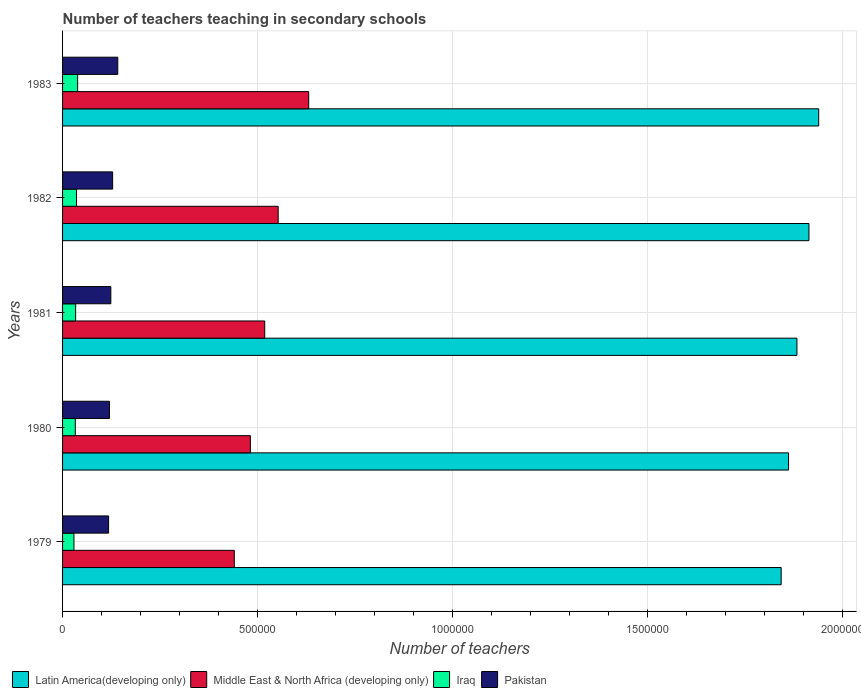How many different coloured bars are there?
Your answer should be compact. 4. How many groups of bars are there?
Give a very brief answer. 5. Are the number of bars per tick equal to the number of legend labels?
Offer a very short reply. Yes. Are the number of bars on each tick of the Y-axis equal?
Your response must be concise. Yes. How many bars are there on the 4th tick from the top?
Offer a terse response. 4. What is the label of the 3rd group of bars from the top?
Keep it short and to the point. 1981. In how many cases, is the number of bars for a given year not equal to the number of legend labels?
Offer a very short reply. 0. What is the number of teachers teaching in secondary schools in Pakistan in 1982?
Give a very brief answer. 1.28e+05. Across all years, what is the maximum number of teachers teaching in secondary schools in Pakistan?
Provide a succinct answer. 1.42e+05. Across all years, what is the minimum number of teachers teaching in secondary schools in Middle East & North Africa (developing only)?
Provide a short and direct response. 4.41e+05. In which year was the number of teachers teaching in secondary schools in Middle East & North Africa (developing only) minimum?
Ensure brevity in your answer.  1979. What is the total number of teachers teaching in secondary schools in Latin America(developing only) in the graph?
Your answer should be very brief. 9.44e+06. What is the difference between the number of teachers teaching in secondary schools in Latin America(developing only) in 1980 and that in 1983?
Your answer should be very brief. -7.73e+04. What is the difference between the number of teachers teaching in secondary schools in Iraq in 1983 and the number of teachers teaching in secondary schools in Middle East & North Africa (developing only) in 1982?
Keep it short and to the point. -5.14e+05. What is the average number of teachers teaching in secondary schools in Pakistan per year?
Provide a short and direct response. 1.26e+05. In the year 1979, what is the difference between the number of teachers teaching in secondary schools in Latin America(developing only) and number of teachers teaching in secondary schools in Iraq?
Your answer should be compact. 1.81e+06. In how many years, is the number of teachers teaching in secondary schools in Latin America(developing only) greater than 1200000 ?
Provide a short and direct response. 5. What is the ratio of the number of teachers teaching in secondary schools in Pakistan in 1980 to that in 1982?
Offer a very short reply. 0.94. Is the number of teachers teaching in secondary schools in Pakistan in 1980 less than that in 1982?
Your response must be concise. Yes. Is the difference between the number of teachers teaching in secondary schools in Latin America(developing only) in 1979 and 1983 greater than the difference between the number of teachers teaching in secondary schools in Iraq in 1979 and 1983?
Your answer should be compact. No. What is the difference between the highest and the second highest number of teachers teaching in secondary schools in Latin America(developing only)?
Offer a very short reply. 2.49e+04. What is the difference between the highest and the lowest number of teachers teaching in secondary schools in Latin America(developing only)?
Your answer should be very brief. 9.62e+04. In how many years, is the number of teachers teaching in secondary schools in Iraq greater than the average number of teachers teaching in secondary schools in Iraq taken over all years?
Your answer should be compact. 2. Is the sum of the number of teachers teaching in secondary schools in Pakistan in 1981 and 1983 greater than the maximum number of teachers teaching in secondary schools in Latin America(developing only) across all years?
Make the answer very short. No. Is it the case that in every year, the sum of the number of teachers teaching in secondary schools in Middle East & North Africa (developing only) and number of teachers teaching in secondary schools in Iraq is greater than the sum of number of teachers teaching in secondary schools in Latin America(developing only) and number of teachers teaching in secondary schools in Pakistan?
Make the answer very short. Yes. What does the 2nd bar from the top in 1983 represents?
Give a very brief answer. Iraq. What does the 2nd bar from the bottom in 1981 represents?
Provide a short and direct response. Middle East & North Africa (developing only). Is it the case that in every year, the sum of the number of teachers teaching in secondary schools in Middle East & North Africa (developing only) and number of teachers teaching in secondary schools in Latin America(developing only) is greater than the number of teachers teaching in secondary schools in Iraq?
Give a very brief answer. Yes. How many bars are there?
Make the answer very short. 20. Are all the bars in the graph horizontal?
Provide a succinct answer. Yes. How many years are there in the graph?
Make the answer very short. 5. Are the values on the major ticks of X-axis written in scientific E-notation?
Provide a succinct answer. No. Does the graph contain grids?
Provide a short and direct response. Yes. How many legend labels are there?
Your response must be concise. 4. How are the legend labels stacked?
Provide a succinct answer. Horizontal. What is the title of the graph?
Make the answer very short. Number of teachers teaching in secondary schools. Does "Brunei Darussalam" appear as one of the legend labels in the graph?
Your answer should be compact. No. What is the label or title of the X-axis?
Offer a very short reply. Number of teachers. What is the label or title of the Y-axis?
Give a very brief answer. Years. What is the Number of teachers of Latin America(developing only) in 1979?
Offer a very short reply. 1.84e+06. What is the Number of teachers in Middle East & North Africa (developing only) in 1979?
Give a very brief answer. 4.41e+05. What is the Number of teachers of Iraq in 1979?
Your answer should be very brief. 2.92e+04. What is the Number of teachers of Pakistan in 1979?
Offer a terse response. 1.18e+05. What is the Number of teachers in Latin America(developing only) in 1980?
Your response must be concise. 1.86e+06. What is the Number of teachers in Middle East & North Africa (developing only) in 1980?
Your answer should be compact. 4.82e+05. What is the Number of teachers in Iraq in 1980?
Offer a very short reply. 3.27e+04. What is the Number of teachers of Pakistan in 1980?
Provide a succinct answer. 1.20e+05. What is the Number of teachers of Latin America(developing only) in 1981?
Your answer should be very brief. 1.88e+06. What is the Number of teachers in Middle East & North Africa (developing only) in 1981?
Provide a succinct answer. 5.19e+05. What is the Number of teachers in Iraq in 1981?
Your answer should be compact. 3.35e+04. What is the Number of teachers in Pakistan in 1981?
Provide a short and direct response. 1.24e+05. What is the Number of teachers in Latin America(developing only) in 1982?
Offer a very short reply. 1.91e+06. What is the Number of teachers in Middle East & North Africa (developing only) in 1982?
Provide a succinct answer. 5.53e+05. What is the Number of teachers in Iraq in 1982?
Your answer should be very brief. 3.58e+04. What is the Number of teachers in Pakistan in 1982?
Offer a very short reply. 1.28e+05. What is the Number of teachers of Latin America(developing only) in 1983?
Your answer should be very brief. 1.94e+06. What is the Number of teachers in Middle East & North Africa (developing only) in 1983?
Provide a succinct answer. 6.31e+05. What is the Number of teachers of Iraq in 1983?
Provide a short and direct response. 3.87e+04. What is the Number of teachers in Pakistan in 1983?
Offer a very short reply. 1.42e+05. Across all years, what is the maximum Number of teachers in Latin America(developing only)?
Keep it short and to the point. 1.94e+06. Across all years, what is the maximum Number of teachers in Middle East & North Africa (developing only)?
Provide a short and direct response. 6.31e+05. Across all years, what is the maximum Number of teachers in Iraq?
Keep it short and to the point. 3.87e+04. Across all years, what is the maximum Number of teachers of Pakistan?
Keep it short and to the point. 1.42e+05. Across all years, what is the minimum Number of teachers in Latin America(developing only)?
Make the answer very short. 1.84e+06. Across all years, what is the minimum Number of teachers of Middle East & North Africa (developing only)?
Your answer should be compact. 4.41e+05. Across all years, what is the minimum Number of teachers of Iraq?
Your answer should be very brief. 2.92e+04. Across all years, what is the minimum Number of teachers of Pakistan?
Offer a terse response. 1.18e+05. What is the total Number of teachers in Latin America(developing only) in the graph?
Provide a succinct answer. 9.44e+06. What is the total Number of teachers of Middle East & North Africa (developing only) in the graph?
Provide a succinct answer. 2.63e+06. What is the total Number of teachers of Iraq in the graph?
Keep it short and to the point. 1.70e+05. What is the total Number of teachers of Pakistan in the graph?
Keep it short and to the point. 6.32e+05. What is the difference between the Number of teachers of Latin America(developing only) in 1979 and that in 1980?
Your answer should be very brief. -1.89e+04. What is the difference between the Number of teachers of Middle East & North Africa (developing only) in 1979 and that in 1980?
Offer a terse response. -4.12e+04. What is the difference between the Number of teachers of Iraq in 1979 and that in 1980?
Provide a succinct answer. -3478. What is the difference between the Number of teachers in Pakistan in 1979 and that in 1980?
Ensure brevity in your answer.  -2204. What is the difference between the Number of teachers of Latin America(developing only) in 1979 and that in 1981?
Keep it short and to the point. -4.04e+04. What is the difference between the Number of teachers of Middle East & North Africa (developing only) in 1979 and that in 1981?
Provide a succinct answer. -7.81e+04. What is the difference between the Number of teachers of Iraq in 1979 and that in 1981?
Your answer should be very brief. -4305. What is the difference between the Number of teachers of Pakistan in 1979 and that in 1981?
Provide a succinct answer. -5740. What is the difference between the Number of teachers of Latin America(developing only) in 1979 and that in 1982?
Make the answer very short. -7.13e+04. What is the difference between the Number of teachers of Middle East & North Africa (developing only) in 1979 and that in 1982?
Give a very brief answer. -1.13e+05. What is the difference between the Number of teachers in Iraq in 1979 and that in 1982?
Provide a short and direct response. -6616. What is the difference between the Number of teachers of Pakistan in 1979 and that in 1982?
Offer a terse response. -1.04e+04. What is the difference between the Number of teachers of Latin America(developing only) in 1979 and that in 1983?
Offer a very short reply. -9.62e+04. What is the difference between the Number of teachers of Middle East & North Africa (developing only) in 1979 and that in 1983?
Make the answer very short. -1.91e+05. What is the difference between the Number of teachers in Iraq in 1979 and that in 1983?
Offer a very short reply. -9469. What is the difference between the Number of teachers of Pakistan in 1979 and that in 1983?
Offer a terse response. -2.35e+04. What is the difference between the Number of teachers in Latin America(developing only) in 1980 and that in 1981?
Ensure brevity in your answer.  -2.15e+04. What is the difference between the Number of teachers in Middle East & North Africa (developing only) in 1980 and that in 1981?
Keep it short and to the point. -3.68e+04. What is the difference between the Number of teachers of Iraq in 1980 and that in 1981?
Offer a very short reply. -827. What is the difference between the Number of teachers of Pakistan in 1980 and that in 1981?
Your answer should be very brief. -3536. What is the difference between the Number of teachers of Latin America(developing only) in 1980 and that in 1982?
Your answer should be compact. -5.24e+04. What is the difference between the Number of teachers in Middle East & North Africa (developing only) in 1980 and that in 1982?
Offer a terse response. -7.13e+04. What is the difference between the Number of teachers in Iraq in 1980 and that in 1982?
Give a very brief answer. -3138. What is the difference between the Number of teachers in Pakistan in 1980 and that in 1982?
Ensure brevity in your answer.  -8186. What is the difference between the Number of teachers of Latin America(developing only) in 1980 and that in 1983?
Give a very brief answer. -7.73e+04. What is the difference between the Number of teachers of Middle East & North Africa (developing only) in 1980 and that in 1983?
Ensure brevity in your answer.  -1.50e+05. What is the difference between the Number of teachers of Iraq in 1980 and that in 1983?
Provide a short and direct response. -5991. What is the difference between the Number of teachers in Pakistan in 1980 and that in 1983?
Keep it short and to the point. -2.13e+04. What is the difference between the Number of teachers of Latin America(developing only) in 1981 and that in 1982?
Provide a succinct answer. -3.09e+04. What is the difference between the Number of teachers in Middle East & North Africa (developing only) in 1981 and that in 1982?
Ensure brevity in your answer.  -3.45e+04. What is the difference between the Number of teachers of Iraq in 1981 and that in 1982?
Offer a very short reply. -2311. What is the difference between the Number of teachers of Pakistan in 1981 and that in 1982?
Keep it short and to the point. -4650. What is the difference between the Number of teachers in Latin America(developing only) in 1981 and that in 1983?
Your answer should be very brief. -5.58e+04. What is the difference between the Number of teachers of Middle East & North Africa (developing only) in 1981 and that in 1983?
Give a very brief answer. -1.13e+05. What is the difference between the Number of teachers of Iraq in 1981 and that in 1983?
Give a very brief answer. -5164. What is the difference between the Number of teachers of Pakistan in 1981 and that in 1983?
Your answer should be very brief. -1.78e+04. What is the difference between the Number of teachers in Latin America(developing only) in 1982 and that in 1983?
Keep it short and to the point. -2.49e+04. What is the difference between the Number of teachers of Middle East & North Africa (developing only) in 1982 and that in 1983?
Your answer should be very brief. -7.83e+04. What is the difference between the Number of teachers of Iraq in 1982 and that in 1983?
Your answer should be very brief. -2853. What is the difference between the Number of teachers of Pakistan in 1982 and that in 1983?
Give a very brief answer. -1.31e+04. What is the difference between the Number of teachers in Latin America(developing only) in 1979 and the Number of teachers in Middle East & North Africa (developing only) in 1980?
Keep it short and to the point. 1.36e+06. What is the difference between the Number of teachers of Latin America(developing only) in 1979 and the Number of teachers of Iraq in 1980?
Make the answer very short. 1.81e+06. What is the difference between the Number of teachers of Latin America(developing only) in 1979 and the Number of teachers of Pakistan in 1980?
Ensure brevity in your answer.  1.72e+06. What is the difference between the Number of teachers of Middle East & North Africa (developing only) in 1979 and the Number of teachers of Iraq in 1980?
Give a very brief answer. 4.08e+05. What is the difference between the Number of teachers in Middle East & North Africa (developing only) in 1979 and the Number of teachers in Pakistan in 1980?
Offer a very short reply. 3.20e+05. What is the difference between the Number of teachers of Iraq in 1979 and the Number of teachers of Pakistan in 1980?
Make the answer very short. -9.11e+04. What is the difference between the Number of teachers in Latin America(developing only) in 1979 and the Number of teachers in Middle East & North Africa (developing only) in 1981?
Offer a very short reply. 1.32e+06. What is the difference between the Number of teachers in Latin America(developing only) in 1979 and the Number of teachers in Iraq in 1981?
Ensure brevity in your answer.  1.81e+06. What is the difference between the Number of teachers in Latin America(developing only) in 1979 and the Number of teachers in Pakistan in 1981?
Your answer should be very brief. 1.72e+06. What is the difference between the Number of teachers of Middle East & North Africa (developing only) in 1979 and the Number of teachers of Iraq in 1981?
Give a very brief answer. 4.07e+05. What is the difference between the Number of teachers of Middle East & North Africa (developing only) in 1979 and the Number of teachers of Pakistan in 1981?
Provide a succinct answer. 3.17e+05. What is the difference between the Number of teachers in Iraq in 1979 and the Number of teachers in Pakistan in 1981?
Offer a very short reply. -9.46e+04. What is the difference between the Number of teachers of Latin America(developing only) in 1979 and the Number of teachers of Middle East & North Africa (developing only) in 1982?
Offer a very short reply. 1.29e+06. What is the difference between the Number of teachers of Latin America(developing only) in 1979 and the Number of teachers of Iraq in 1982?
Keep it short and to the point. 1.81e+06. What is the difference between the Number of teachers of Latin America(developing only) in 1979 and the Number of teachers of Pakistan in 1982?
Provide a succinct answer. 1.71e+06. What is the difference between the Number of teachers of Middle East & North Africa (developing only) in 1979 and the Number of teachers of Iraq in 1982?
Offer a terse response. 4.05e+05. What is the difference between the Number of teachers in Middle East & North Africa (developing only) in 1979 and the Number of teachers in Pakistan in 1982?
Give a very brief answer. 3.12e+05. What is the difference between the Number of teachers of Iraq in 1979 and the Number of teachers of Pakistan in 1982?
Offer a very short reply. -9.93e+04. What is the difference between the Number of teachers of Latin America(developing only) in 1979 and the Number of teachers of Middle East & North Africa (developing only) in 1983?
Your response must be concise. 1.21e+06. What is the difference between the Number of teachers in Latin America(developing only) in 1979 and the Number of teachers in Iraq in 1983?
Your answer should be compact. 1.80e+06. What is the difference between the Number of teachers in Latin America(developing only) in 1979 and the Number of teachers in Pakistan in 1983?
Your response must be concise. 1.70e+06. What is the difference between the Number of teachers of Middle East & North Africa (developing only) in 1979 and the Number of teachers of Iraq in 1983?
Your response must be concise. 4.02e+05. What is the difference between the Number of teachers of Middle East & North Africa (developing only) in 1979 and the Number of teachers of Pakistan in 1983?
Your response must be concise. 2.99e+05. What is the difference between the Number of teachers in Iraq in 1979 and the Number of teachers in Pakistan in 1983?
Give a very brief answer. -1.12e+05. What is the difference between the Number of teachers of Latin America(developing only) in 1980 and the Number of teachers of Middle East & North Africa (developing only) in 1981?
Offer a very short reply. 1.34e+06. What is the difference between the Number of teachers of Latin America(developing only) in 1980 and the Number of teachers of Iraq in 1981?
Ensure brevity in your answer.  1.83e+06. What is the difference between the Number of teachers in Latin America(developing only) in 1980 and the Number of teachers in Pakistan in 1981?
Make the answer very short. 1.74e+06. What is the difference between the Number of teachers of Middle East & North Africa (developing only) in 1980 and the Number of teachers of Iraq in 1981?
Provide a succinct answer. 4.48e+05. What is the difference between the Number of teachers of Middle East & North Africa (developing only) in 1980 and the Number of teachers of Pakistan in 1981?
Offer a terse response. 3.58e+05. What is the difference between the Number of teachers in Iraq in 1980 and the Number of teachers in Pakistan in 1981?
Your answer should be compact. -9.11e+04. What is the difference between the Number of teachers of Latin America(developing only) in 1980 and the Number of teachers of Middle East & North Africa (developing only) in 1982?
Provide a short and direct response. 1.31e+06. What is the difference between the Number of teachers of Latin America(developing only) in 1980 and the Number of teachers of Iraq in 1982?
Your answer should be compact. 1.83e+06. What is the difference between the Number of teachers of Latin America(developing only) in 1980 and the Number of teachers of Pakistan in 1982?
Ensure brevity in your answer.  1.73e+06. What is the difference between the Number of teachers of Middle East & North Africa (developing only) in 1980 and the Number of teachers of Iraq in 1982?
Ensure brevity in your answer.  4.46e+05. What is the difference between the Number of teachers in Middle East & North Africa (developing only) in 1980 and the Number of teachers in Pakistan in 1982?
Offer a terse response. 3.53e+05. What is the difference between the Number of teachers of Iraq in 1980 and the Number of teachers of Pakistan in 1982?
Your answer should be compact. -9.58e+04. What is the difference between the Number of teachers in Latin America(developing only) in 1980 and the Number of teachers in Middle East & North Africa (developing only) in 1983?
Make the answer very short. 1.23e+06. What is the difference between the Number of teachers in Latin America(developing only) in 1980 and the Number of teachers in Iraq in 1983?
Your answer should be very brief. 1.82e+06. What is the difference between the Number of teachers of Latin America(developing only) in 1980 and the Number of teachers of Pakistan in 1983?
Offer a terse response. 1.72e+06. What is the difference between the Number of teachers in Middle East & North Africa (developing only) in 1980 and the Number of teachers in Iraq in 1983?
Give a very brief answer. 4.43e+05. What is the difference between the Number of teachers in Middle East & North Africa (developing only) in 1980 and the Number of teachers in Pakistan in 1983?
Keep it short and to the point. 3.40e+05. What is the difference between the Number of teachers in Iraq in 1980 and the Number of teachers in Pakistan in 1983?
Your answer should be compact. -1.09e+05. What is the difference between the Number of teachers in Latin America(developing only) in 1981 and the Number of teachers in Middle East & North Africa (developing only) in 1982?
Provide a short and direct response. 1.33e+06. What is the difference between the Number of teachers in Latin America(developing only) in 1981 and the Number of teachers in Iraq in 1982?
Your answer should be very brief. 1.85e+06. What is the difference between the Number of teachers of Latin America(developing only) in 1981 and the Number of teachers of Pakistan in 1982?
Offer a terse response. 1.76e+06. What is the difference between the Number of teachers of Middle East & North Africa (developing only) in 1981 and the Number of teachers of Iraq in 1982?
Your answer should be very brief. 4.83e+05. What is the difference between the Number of teachers in Middle East & North Africa (developing only) in 1981 and the Number of teachers in Pakistan in 1982?
Make the answer very short. 3.90e+05. What is the difference between the Number of teachers of Iraq in 1981 and the Number of teachers of Pakistan in 1982?
Offer a terse response. -9.50e+04. What is the difference between the Number of teachers in Latin America(developing only) in 1981 and the Number of teachers in Middle East & North Africa (developing only) in 1983?
Your answer should be compact. 1.25e+06. What is the difference between the Number of teachers in Latin America(developing only) in 1981 and the Number of teachers in Iraq in 1983?
Provide a short and direct response. 1.85e+06. What is the difference between the Number of teachers of Latin America(developing only) in 1981 and the Number of teachers of Pakistan in 1983?
Provide a succinct answer. 1.74e+06. What is the difference between the Number of teachers in Middle East & North Africa (developing only) in 1981 and the Number of teachers in Iraq in 1983?
Your answer should be compact. 4.80e+05. What is the difference between the Number of teachers in Middle East & North Africa (developing only) in 1981 and the Number of teachers in Pakistan in 1983?
Your answer should be compact. 3.77e+05. What is the difference between the Number of teachers in Iraq in 1981 and the Number of teachers in Pakistan in 1983?
Offer a very short reply. -1.08e+05. What is the difference between the Number of teachers in Latin America(developing only) in 1982 and the Number of teachers in Middle East & North Africa (developing only) in 1983?
Provide a succinct answer. 1.28e+06. What is the difference between the Number of teachers in Latin America(developing only) in 1982 and the Number of teachers in Iraq in 1983?
Keep it short and to the point. 1.88e+06. What is the difference between the Number of teachers of Latin America(developing only) in 1982 and the Number of teachers of Pakistan in 1983?
Your answer should be compact. 1.77e+06. What is the difference between the Number of teachers in Middle East & North Africa (developing only) in 1982 and the Number of teachers in Iraq in 1983?
Provide a succinct answer. 5.14e+05. What is the difference between the Number of teachers in Middle East & North Africa (developing only) in 1982 and the Number of teachers in Pakistan in 1983?
Your response must be concise. 4.11e+05. What is the difference between the Number of teachers in Iraq in 1982 and the Number of teachers in Pakistan in 1983?
Offer a very short reply. -1.06e+05. What is the average Number of teachers of Latin America(developing only) per year?
Offer a terse response. 1.89e+06. What is the average Number of teachers in Middle East & North Africa (developing only) per year?
Provide a succinct answer. 5.25e+05. What is the average Number of teachers in Iraq per year?
Your response must be concise. 3.40e+04. What is the average Number of teachers of Pakistan per year?
Keep it short and to the point. 1.26e+05. In the year 1979, what is the difference between the Number of teachers in Latin America(developing only) and Number of teachers in Middle East & North Africa (developing only)?
Provide a succinct answer. 1.40e+06. In the year 1979, what is the difference between the Number of teachers of Latin America(developing only) and Number of teachers of Iraq?
Give a very brief answer. 1.81e+06. In the year 1979, what is the difference between the Number of teachers in Latin America(developing only) and Number of teachers in Pakistan?
Offer a very short reply. 1.73e+06. In the year 1979, what is the difference between the Number of teachers in Middle East & North Africa (developing only) and Number of teachers in Iraq?
Make the answer very short. 4.11e+05. In the year 1979, what is the difference between the Number of teachers of Middle East & North Africa (developing only) and Number of teachers of Pakistan?
Offer a terse response. 3.22e+05. In the year 1979, what is the difference between the Number of teachers in Iraq and Number of teachers in Pakistan?
Your answer should be very brief. -8.89e+04. In the year 1980, what is the difference between the Number of teachers of Latin America(developing only) and Number of teachers of Middle East & North Africa (developing only)?
Offer a very short reply. 1.38e+06. In the year 1980, what is the difference between the Number of teachers in Latin America(developing only) and Number of teachers in Iraq?
Make the answer very short. 1.83e+06. In the year 1980, what is the difference between the Number of teachers in Latin America(developing only) and Number of teachers in Pakistan?
Provide a short and direct response. 1.74e+06. In the year 1980, what is the difference between the Number of teachers of Middle East & North Africa (developing only) and Number of teachers of Iraq?
Ensure brevity in your answer.  4.49e+05. In the year 1980, what is the difference between the Number of teachers of Middle East & North Africa (developing only) and Number of teachers of Pakistan?
Offer a terse response. 3.61e+05. In the year 1980, what is the difference between the Number of teachers in Iraq and Number of teachers in Pakistan?
Provide a short and direct response. -8.76e+04. In the year 1981, what is the difference between the Number of teachers in Latin America(developing only) and Number of teachers in Middle East & North Africa (developing only)?
Provide a short and direct response. 1.37e+06. In the year 1981, what is the difference between the Number of teachers of Latin America(developing only) and Number of teachers of Iraq?
Offer a very short reply. 1.85e+06. In the year 1981, what is the difference between the Number of teachers in Latin America(developing only) and Number of teachers in Pakistan?
Your response must be concise. 1.76e+06. In the year 1981, what is the difference between the Number of teachers in Middle East & North Africa (developing only) and Number of teachers in Iraq?
Ensure brevity in your answer.  4.85e+05. In the year 1981, what is the difference between the Number of teachers in Middle East & North Africa (developing only) and Number of teachers in Pakistan?
Your answer should be very brief. 3.95e+05. In the year 1981, what is the difference between the Number of teachers of Iraq and Number of teachers of Pakistan?
Keep it short and to the point. -9.03e+04. In the year 1982, what is the difference between the Number of teachers in Latin America(developing only) and Number of teachers in Middle East & North Africa (developing only)?
Keep it short and to the point. 1.36e+06. In the year 1982, what is the difference between the Number of teachers in Latin America(developing only) and Number of teachers in Iraq?
Your answer should be compact. 1.88e+06. In the year 1982, what is the difference between the Number of teachers in Latin America(developing only) and Number of teachers in Pakistan?
Make the answer very short. 1.79e+06. In the year 1982, what is the difference between the Number of teachers of Middle East & North Africa (developing only) and Number of teachers of Iraq?
Your answer should be compact. 5.17e+05. In the year 1982, what is the difference between the Number of teachers of Middle East & North Africa (developing only) and Number of teachers of Pakistan?
Your answer should be very brief. 4.25e+05. In the year 1982, what is the difference between the Number of teachers of Iraq and Number of teachers of Pakistan?
Give a very brief answer. -9.26e+04. In the year 1983, what is the difference between the Number of teachers of Latin America(developing only) and Number of teachers of Middle East & North Africa (developing only)?
Provide a short and direct response. 1.31e+06. In the year 1983, what is the difference between the Number of teachers in Latin America(developing only) and Number of teachers in Iraq?
Your answer should be very brief. 1.90e+06. In the year 1983, what is the difference between the Number of teachers of Latin America(developing only) and Number of teachers of Pakistan?
Your answer should be very brief. 1.80e+06. In the year 1983, what is the difference between the Number of teachers in Middle East & North Africa (developing only) and Number of teachers in Iraq?
Your response must be concise. 5.93e+05. In the year 1983, what is the difference between the Number of teachers in Middle East & North Africa (developing only) and Number of teachers in Pakistan?
Make the answer very short. 4.90e+05. In the year 1983, what is the difference between the Number of teachers of Iraq and Number of teachers of Pakistan?
Keep it short and to the point. -1.03e+05. What is the ratio of the Number of teachers in Latin America(developing only) in 1979 to that in 1980?
Your answer should be very brief. 0.99. What is the ratio of the Number of teachers of Middle East & North Africa (developing only) in 1979 to that in 1980?
Make the answer very short. 0.91. What is the ratio of the Number of teachers of Iraq in 1979 to that in 1980?
Offer a very short reply. 0.89. What is the ratio of the Number of teachers of Pakistan in 1979 to that in 1980?
Offer a very short reply. 0.98. What is the ratio of the Number of teachers in Latin America(developing only) in 1979 to that in 1981?
Provide a succinct answer. 0.98. What is the ratio of the Number of teachers of Middle East & North Africa (developing only) in 1979 to that in 1981?
Provide a short and direct response. 0.85. What is the ratio of the Number of teachers in Iraq in 1979 to that in 1981?
Your answer should be compact. 0.87. What is the ratio of the Number of teachers of Pakistan in 1979 to that in 1981?
Offer a very short reply. 0.95. What is the ratio of the Number of teachers of Latin America(developing only) in 1979 to that in 1982?
Your response must be concise. 0.96. What is the ratio of the Number of teachers in Middle East & North Africa (developing only) in 1979 to that in 1982?
Give a very brief answer. 0.8. What is the ratio of the Number of teachers in Iraq in 1979 to that in 1982?
Your response must be concise. 0.82. What is the ratio of the Number of teachers of Pakistan in 1979 to that in 1982?
Your answer should be very brief. 0.92. What is the ratio of the Number of teachers in Latin America(developing only) in 1979 to that in 1983?
Offer a terse response. 0.95. What is the ratio of the Number of teachers of Middle East & North Africa (developing only) in 1979 to that in 1983?
Ensure brevity in your answer.  0.7. What is the ratio of the Number of teachers in Iraq in 1979 to that in 1983?
Make the answer very short. 0.76. What is the ratio of the Number of teachers of Pakistan in 1979 to that in 1983?
Your answer should be very brief. 0.83. What is the ratio of the Number of teachers of Latin America(developing only) in 1980 to that in 1981?
Provide a short and direct response. 0.99. What is the ratio of the Number of teachers in Middle East & North Africa (developing only) in 1980 to that in 1981?
Provide a succinct answer. 0.93. What is the ratio of the Number of teachers in Iraq in 1980 to that in 1981?
Offer a terse response. 0.98. What is the ratio of the Number of teachers of Pakistan in 1980 to that in 1981?
Your answer should be compact. 0.97. What is the ratio of the Number of teachers in Latin America(developing only) in 1980 to that in 1982?
Offer a terse response. 0.97. What is the ratio of the Number of teachers in Middle East & North Africa (developing only) in 1980 to that in 1982?
Offer a very short reply. 0.87. What is the ratio of the Number of teachers of Iraq in 1980 to that in 1982?
Your response must be concise. 0.91. What is the ratio of the Number of teachers in Pakistan in 1980 to that in 1982?
Offer a very short reply. 0.94. What is the ratio of the Number of teachers in Latin America(developing only) in 1980 to that in 1983?
Offer a terse response. 0.96. What is the ratio of the Number of teachers in Middle East & North Africa (developing only) in 1980 to that in 1983?
Give a very brief answer. 0.76. What is the ratio of the Number of teachers of Iraq in 1980 to that in 1983?
Give a very brief answer. 0.85. What is the ratio of the Number of teachers in Pakistan in 1980 to that in 1983?
Your answer should be very brief. 0.85. What is the ratio of the Number of teachers of Latin America(developing only) in 1981 to that in 1982?
Offer a terse response. 0.98. What is the ratio of the Number of teachers in Middle East & North Africa (developing only) in 1981 to that in 1982?
Your response must be concise. 0.94. What is the ratio of the Number of teachers of Iraq in 1981 to that in 1982?
Make the answer very short. 0.94. What is the ratio of the Number of teachers of Pakistan in 1981 to that in 1982?
Provide a short and direct response. 0.96. What is the ratio of the Number of teachers in Latin America(developing only) in 1981 to that in 1983?
Provide a short and direct response. 0.97. What is the ratio of the Number of teachers of Middle East & North Africa (developing only) in 1981 to that in 1983?
Your answer should be compact. 0.82. What is the ratio of the Number of teachers in Iraq in 1981 to that in 1983?
Provide a succinct answer. 0.87. What is the ratio of the Number of teachers of Pakistan in 1981 to that in 1983?
Provide a short and direct response. 0.87. What is the ratio of the Number of teachers in Latin America(developing only) in 1982 to that in 1983?
Keep it short and to the point. 0.99. What is the ratio of the Number of teachers of Middle East & North Africa (developing only) in 1982 to that in 1983?
Your answer should be very brief. 0.88. What is the ratio of the Number of teachers of Iraq in 1982 to that in 1983?
Offer a terse response. 0.93. What is the ratio of the Number of teachers of Pakistan in 1982 to that in 1983?
Ensure brevity in your answer.  0.91. What is the difference between the highest and the second highest Number of teachers of Latin America(developing only)?
Ensure brevity in your answer.  2.49e+04. What is the difference between the highest and the second highest Number of teachers in Middle East & North Africa (developing only)?
Provide a succinct answer. 7.83e+04. What is the difference between the highest and the second highest Number of teachers of Iraq?
Offer a terse response. 2853. What is the difference between the highest and the second highest Number of teachers of Pakistan?
Offer a terse response. 1.31e+04. What is the difference between the highest and the lowest Number of teachers of Latin America(developing only)?
Your answer should be very brief. 9.62e+04. What is the difference between the highest and the lowest Number of teachers of Middle East & North Africa (developing only)?
Offer a terse response. 1.91e+05. What is the difference between the highest and the lowest Number of teachers of Iraq?
Your response must be concise. 9469. What is the difference between the highest and the lowest Number of teachers of Pakistan?
Ensure brevity in your answer.  2.35e+04. 